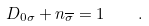Convert formula to latex. <formula><loc_0><loc_0><loc_500><loc_500>D _ { 0 \sigma } + n _ { \overline { \sigma } } = 1 \quad .</formula> 